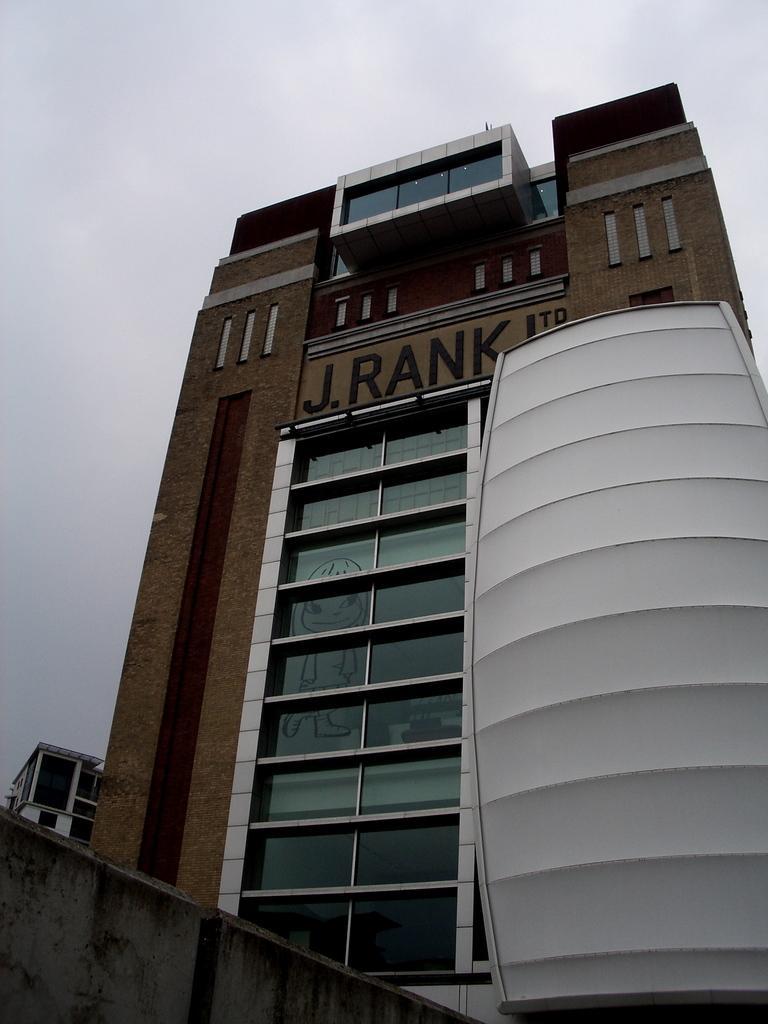Describe this image in one or two sentences. There is a tall building it has many windows and there is a white color shield kept to the building, in the background there is a sky. 